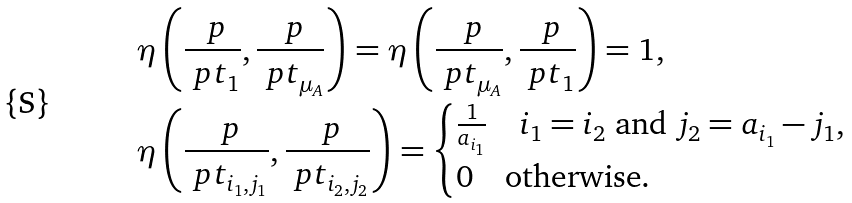Convert formula to latex. <formula><loc_0><loc_0><loc_500><loc_500>& \ \eta \left ( \frac { \ p } { \ p t _ { 1 } } , \frac { \ p } { \ p t _ { \mu _ { A } } } \right ) = \eta \left ( \frac { \ p } { \ p t _ { \mu _ { A } } } , \frac { \ p } { \ p t _ { 1 } } \right ) = 1 , \\ & \ \eta \left ( \frac { \ p } { \ p t _ { i _ { 1 } , j _ { 1 } } } , \frac { \ p } { \ p t _ { i _ { 2 } , j _ { 2 } } } \right ) = \begin{cases} \frac { 1 } { a _ { i _ { 1 } } } \quad i _ { 1 } = i _ { 2 } \text { and } j _ { 2 } = a _ { i _ { 1 } } - j _ { 1 } , \\ 0 \quad \text {otherwise} . \end{cases}</formula> 